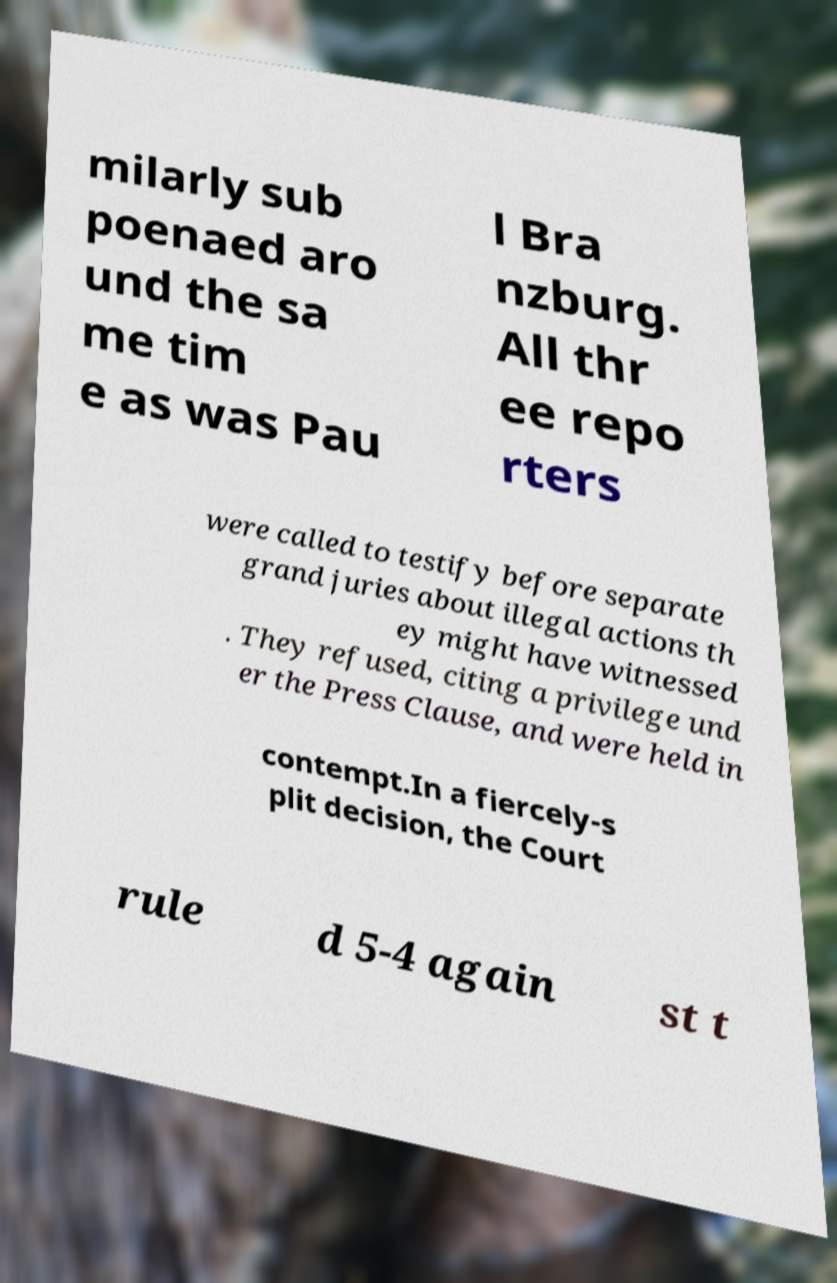Please identify and transcribe the text found in this image. milarly sub poenaed aro und the sa me tim e as was Pau l Bra nzburg. All thr ee repo rters were called to testify before separate grand juries about illegal actions th ey might have witnessed . They refused, citing a privilege und er the Press Clause, and were held in contempt.In a fiercely-s plit decision, the Court rule d 5-4 again st t 